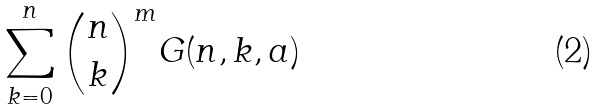Convert formula to latex. <formula><loc_0><loc_0><loc_500><loc_500>\sum _ { k = 0 } ^ { n } \binom { n } { k } ^ { m } G ( n , k , a )</formula> 